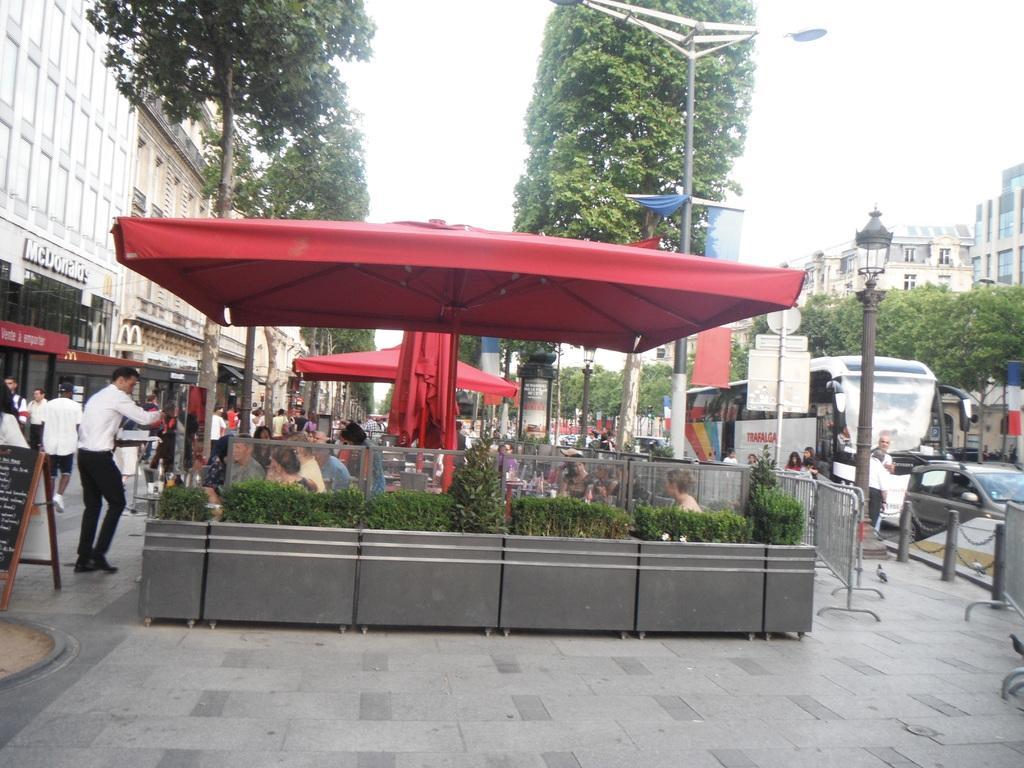Please provide a concise description of this image. In this image in the front there is an object which is gray in colour and on the top of the object there is a glass, behind the glass there are plants, persons. In the center there are tents which are red in colour. In the background there are buildings, trees, poles and vehicles. On the left side there is a board with some text written on it. On the right side there are poles and there are trees, buildings. 